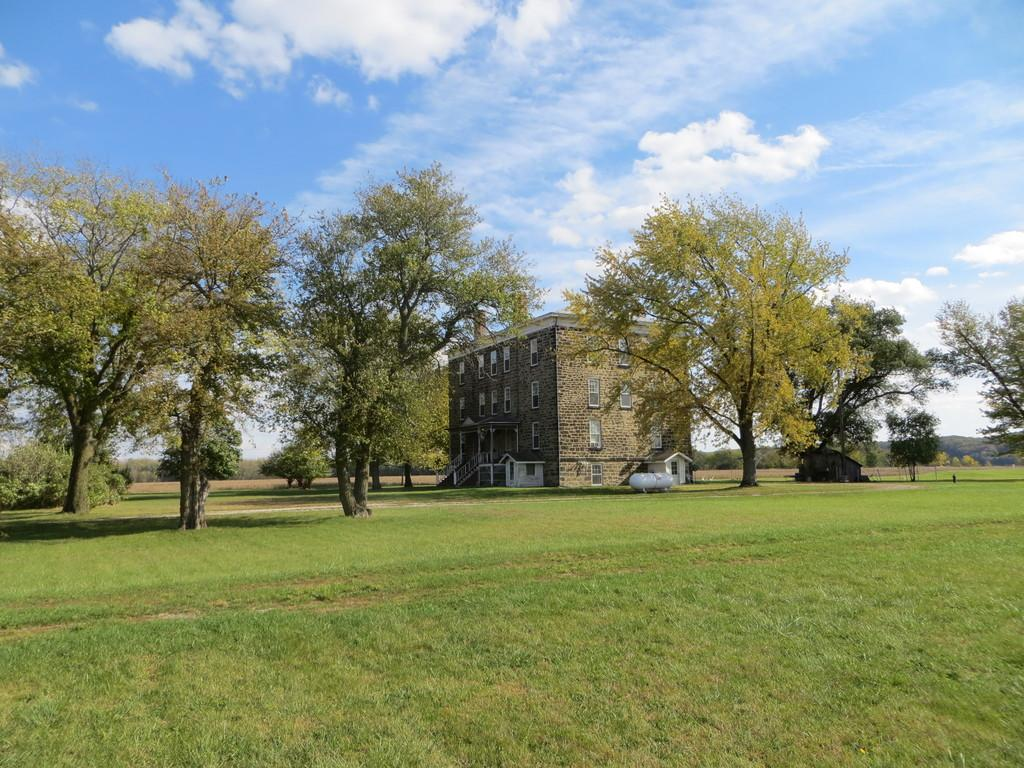What can be seen in the foreground of the image? There is an open area in the foreground of the image. What is visible in the background of the image? There are trees and a building in the background of the image. What is the condition of the sky in the image? The sky is clear and visible in the background of the image. What type of sound can be heard coming from the mountain in the image? There is no mountain present in the image, so it is not possible to determine what, if any, sound might be heard. How can the height of the trees be measured in the image? The image is a two-dimensional representation, so it is not possible to measure the height of the trees directly from the image. 